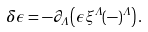<formula> <loc_0><loc_0><loc_500><loc_500>\delta \epsilon = - \partial _ { \Lambda } \left ( \epsilon \xi ^ { \Lambda } ( - ) ^ { \Lambda } \right ) .</formula> 